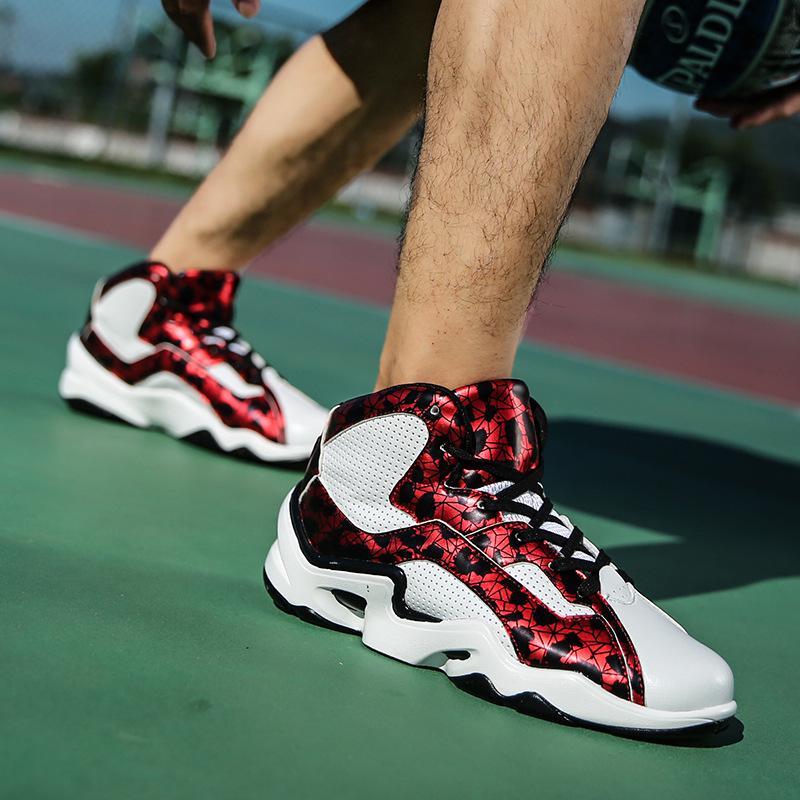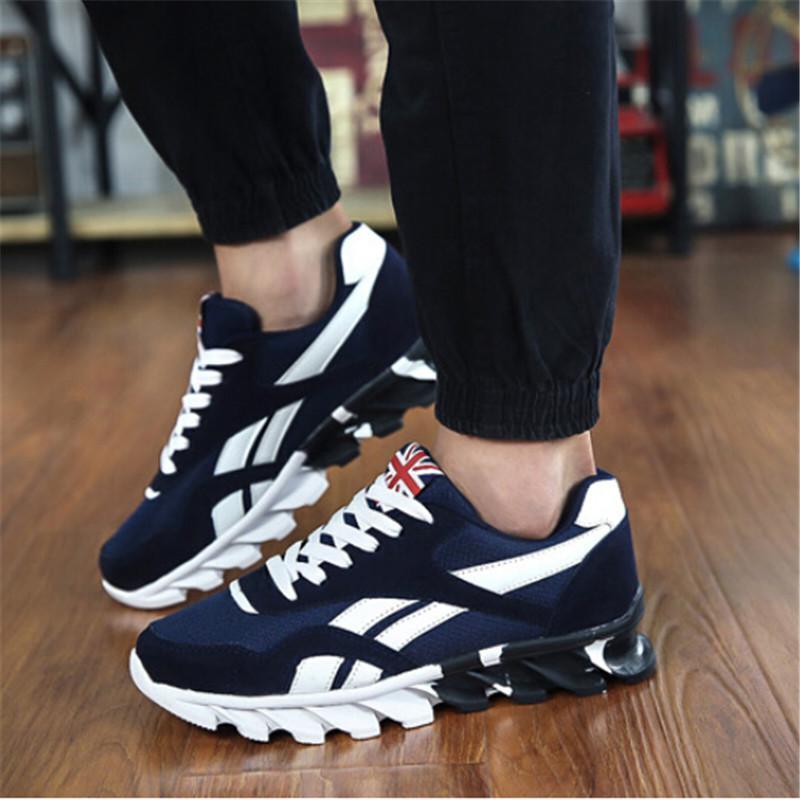The first image is the image on the left, the second image is the image on the right. Evaluate the accuracy of this statement regarding the images: "There are two shoes in the left image". Is it true? Answer yes or no. Yes. The first image is the image on the left, the second image is the image on the right. For the images displayed, is the sentence "The feet and legs of many people running in a race are shown." factually correct? Answer yes or no. No. 